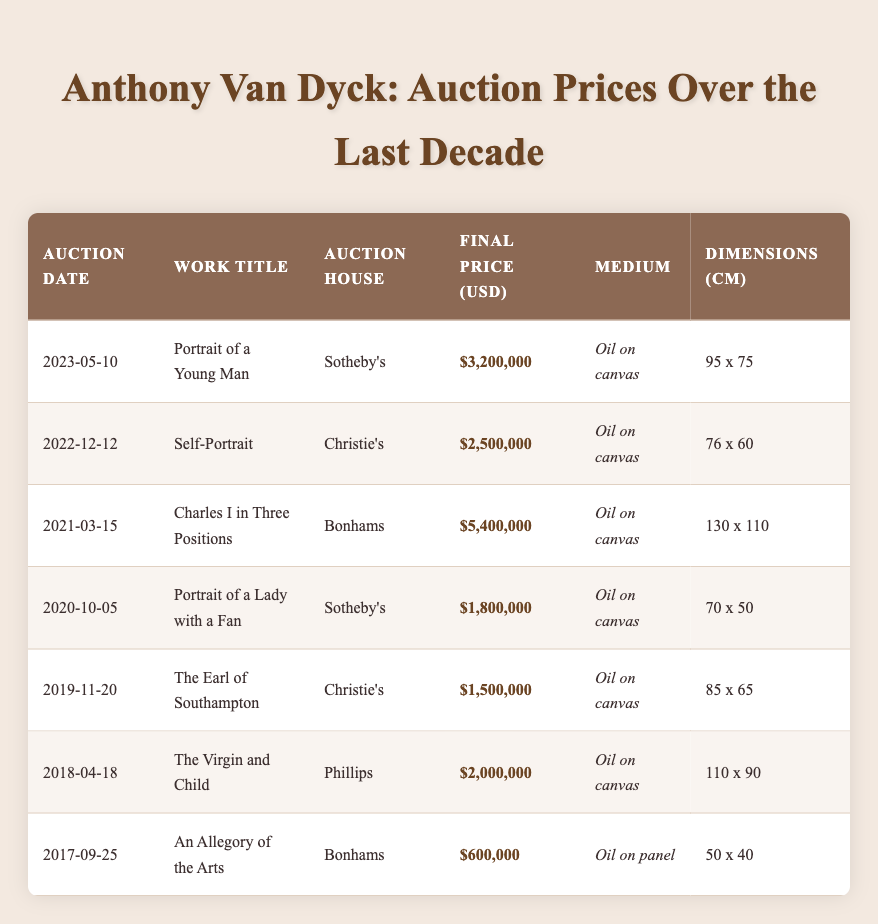What was the highest final price for a Van Dyke work sold in the last decade? The highest final price listed is $5,400,000 for "Charles I in Three Positions", auctioned on March 15, 2021, at Bonhams.
Answer: $5,400,000 Which auction house sold the "Portrait of a Young Man"? The "Portrait of a Young Man" was sold by Sotheby's on May 10, 2023.
Answer: Sotheby's What is the average final price of Van Dyke's works sold in the past decade? The final prices are $3,200,000, $2,500,000, $5,400,000, $1,800,000, $1,500,000, $2,000,000, and $600,000. Adding them gives $17,000,000, and dividing by 7 gives an average of $2,428,571.43.
Answer: $2,428,571.43 Was the "Self-Portrait" sold for more than $2,000,000? The final price for the "Self-Portrait" is $2,500,000, which is greater than $2,000,000, confirming that it was sold for more.
Answer: Yes How many works were sold at Christie's, and what were their titles? There are two works sold at Christie's: "Self-Portrait" on December 12, 2022, and "The Earl of Southampton" on November 20, 2019.
Answer: 2 works: "Self-Portrait" and "The Earl of Southampton" Which work has the largest dimensions, and what are those dimensions? The work "Charles I in Three Positions" has dimensions of 130 x 110 cm, which is the largest compared to others.
Answer: 130 x 110 cm What is the difference in final price between the highest and lowest valued works sold? The highest final price is $5,400,000 for "Charles I in Three Positions" and the lowest is $600,000 for "An Allegory of the Arts". The difference is $5,400,000 - $600,000 = $4,800,000.
Answer: $4,800,000 Was "The Virgin and Child" auctioned by Phillips, and what was its final price? Yes, "The Virgin and Child" was auctioned by Phillips, and its final price was $2,000,000.
Answer: Yes, $2,000,000 